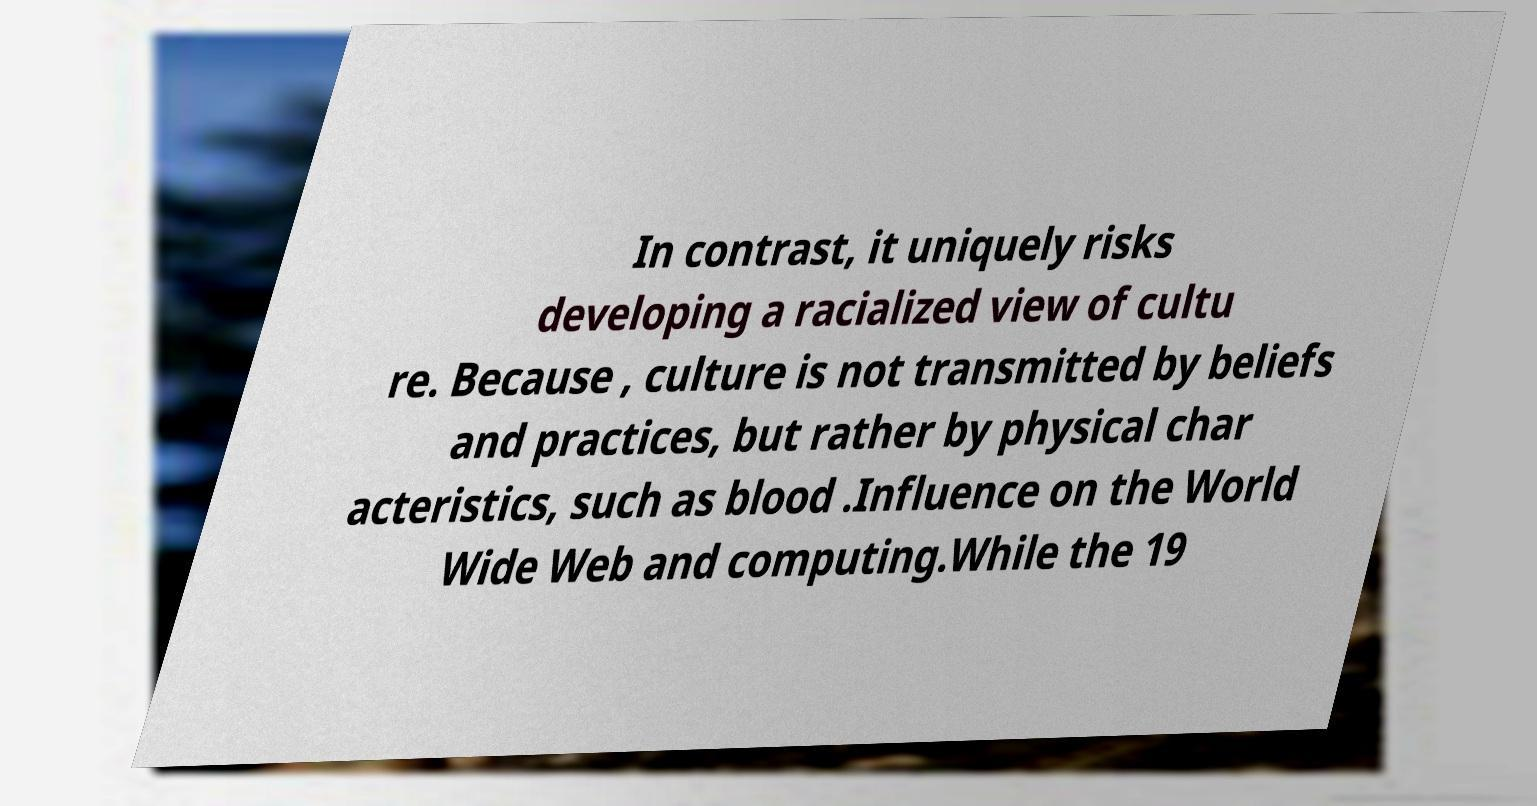Can you read and provide the text displayed in the image?This photo seems to have some interesting text. Can you extract and type it out for me? In contrast, it uniquely risks developing a racialized view of cultu re. Because , culture is not transmitted by beliefs and practices, but rather by physical char acteristics, such as blood .Influence on the World Wide Web and computing.While the 19 